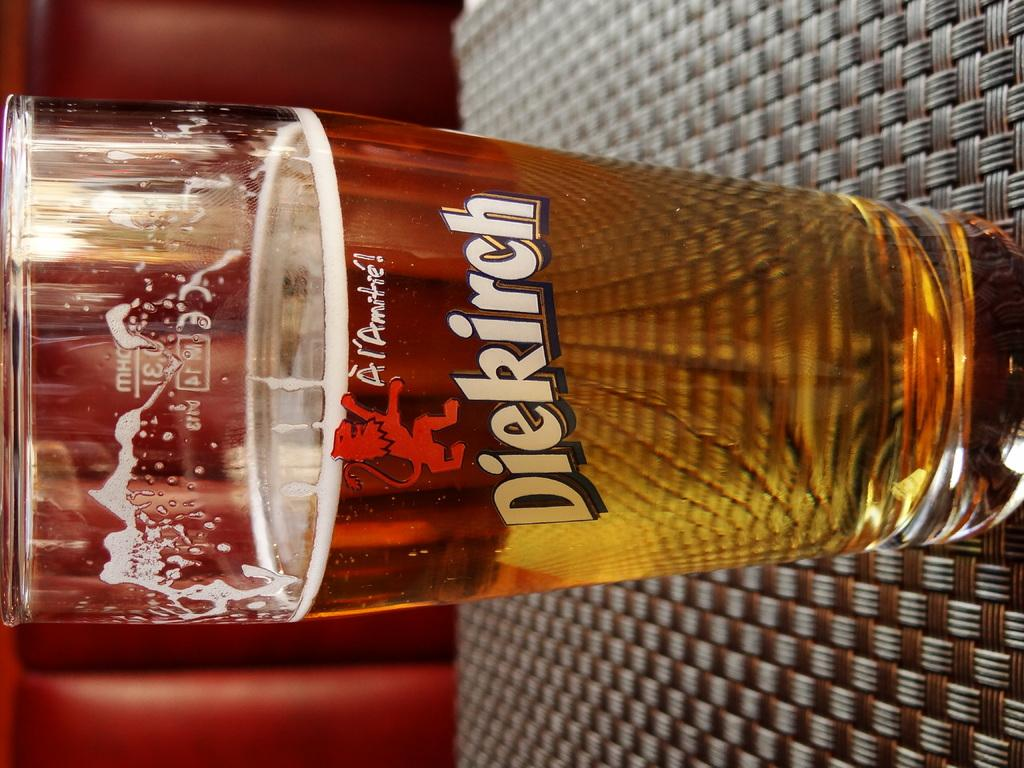<image>
Relay a brief, clear account of the picture shown. A Diekirch glass with beer sitting on a table 